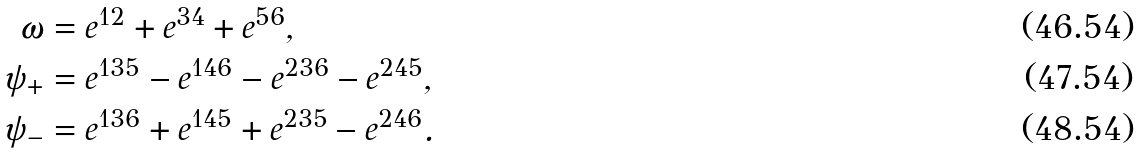Convert formula to latex. <formula><loc_0><loc_0><loc_500><loc_500>\omega & = e ^ { 1 2 } + e ^ { 3 4 } + e ^ { 5 6 } , \\ \psi _ { + } & = e ^ { 1 3 5 } - e ^ { 1 4 6 } - e ^ { 2 3 6 } - e ^ { 2 4 5 } , \\ \psi _ { - } & = e ^ { 1 3 6 } + e ^ { 1 4 5 } + e ^ { 2 3 5 } - e ^ { 2 4 6 } .</formula> 